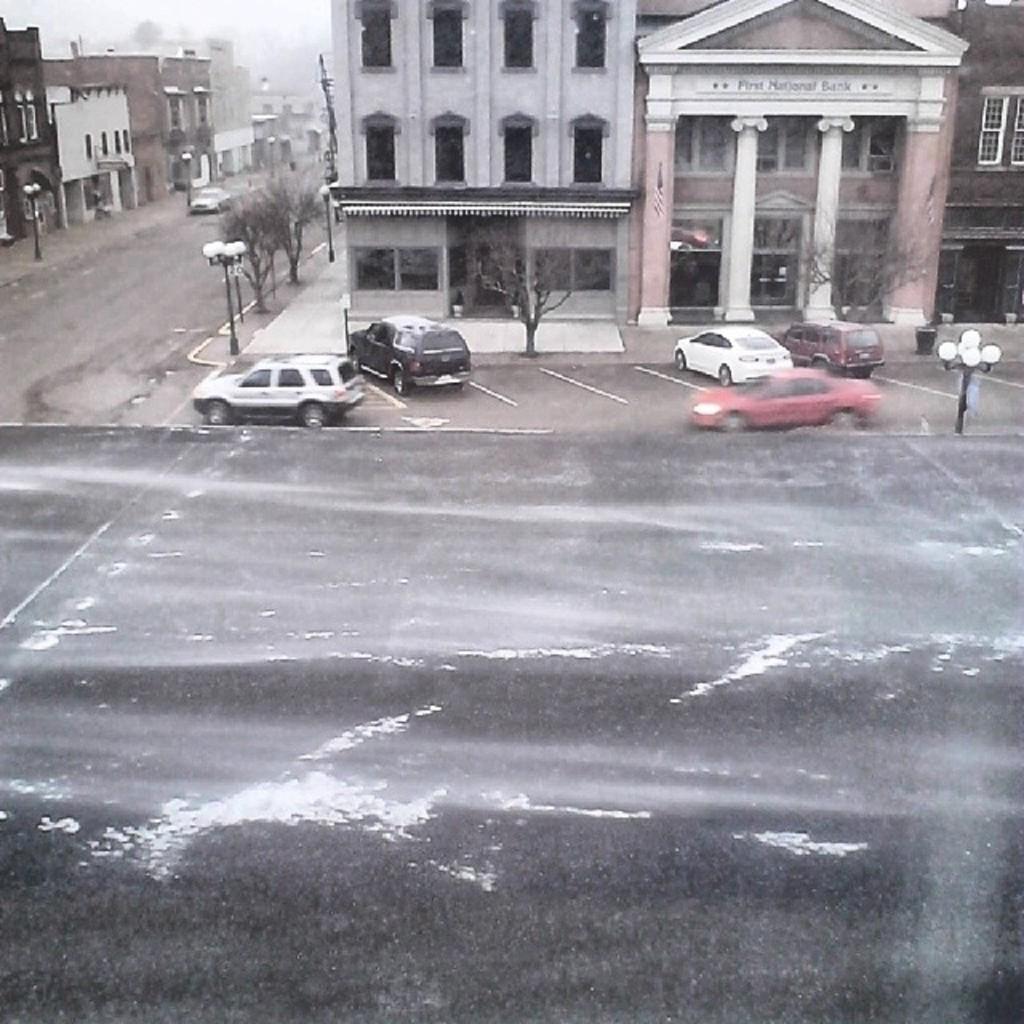Could you give a brief overview of what you see in this image? In this image I can see a road and vehicles on it. I can also see number of street lights, trees and buildings. 